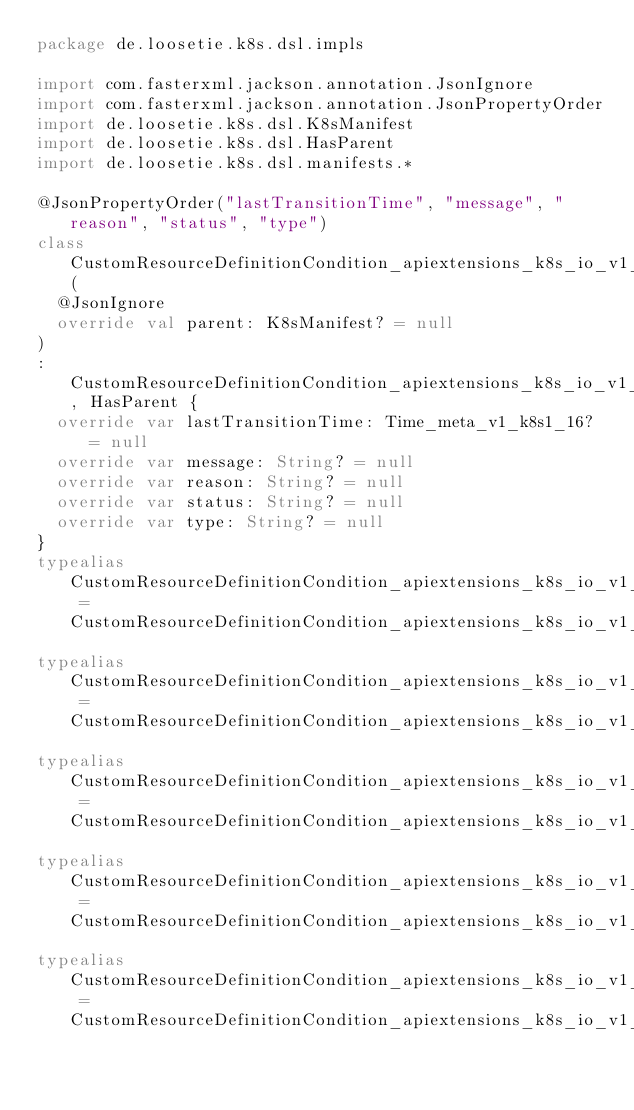<code> <loc_0><loc_0><loc_500><loc_500><_Kotlin_>package de.loosetie.k8s.dsl.impls

import com.fasterxml.jackson.annotation.JsonIgnore
import com.fasterxml.jackson.annotation.JsonPropertyOrder
import de.loosetie.k8s.dsl.K8sManifest
import de.loosetie.k8s.dsl.HasParent
import de.loosetie.k8s.dsl.manifests.*

@JsonPropertyOrder("lastTransitionTime", "message", "reason", "status", "type")
class CustomResourceDefinitionCondition_apiextensions_k8s_io_v1_k8s1_16Impl(
  @JsonIgnore
  override val parent: K8sManifest? = null
)
: CustomResourceDefinitionCondition_apiextensions_k8s_io_v1_k8s1_16, HasParent {
  override var lastTransitionTime: Time_meta_v1_k8s1_16? = null
  override var message: String? = null
  override var reason: String? = null
  override var status: String? = null
  override var type: String? = null
}
typealias CustomResourceDefinitionCondition_apiextensions_k8s_io_v1_k8s1_17Impl = CustomResourceDefinitionCondition_apiextensions_k8s_io_v1_k8s1_16Impl
typealias CustomResourceDefinitionCondition_apiextensions_k8s_io_v1_k8s1_18Impl = CustomResourceDefinitionCondition_apiextensions_k8s_io_v1_k8s1_17Impl
typealias CustomResourceDefinitionCondition_apiextensions_k8s_io_v1_k8s1_19Impl = CustomResourceDefinitionCondition_apiextensions_k8s_io_v1_k8s1_18Impl
typealias CustomResourceDefinitionCondition_apiextensions_k8s_io_v1_k8s1_20Impl = CustomResourceDefinitionCondition_apiextensions_k8s_io_v1_k8s1_19Impl
typealias CustomResourceDefinitionCondition_apiextensions_k8s_io_v1_k8s1_21Impl = CustomResourceDefinitionCondition_apiextensions_k8s_io_v1_k8s1_20Impl</code> 